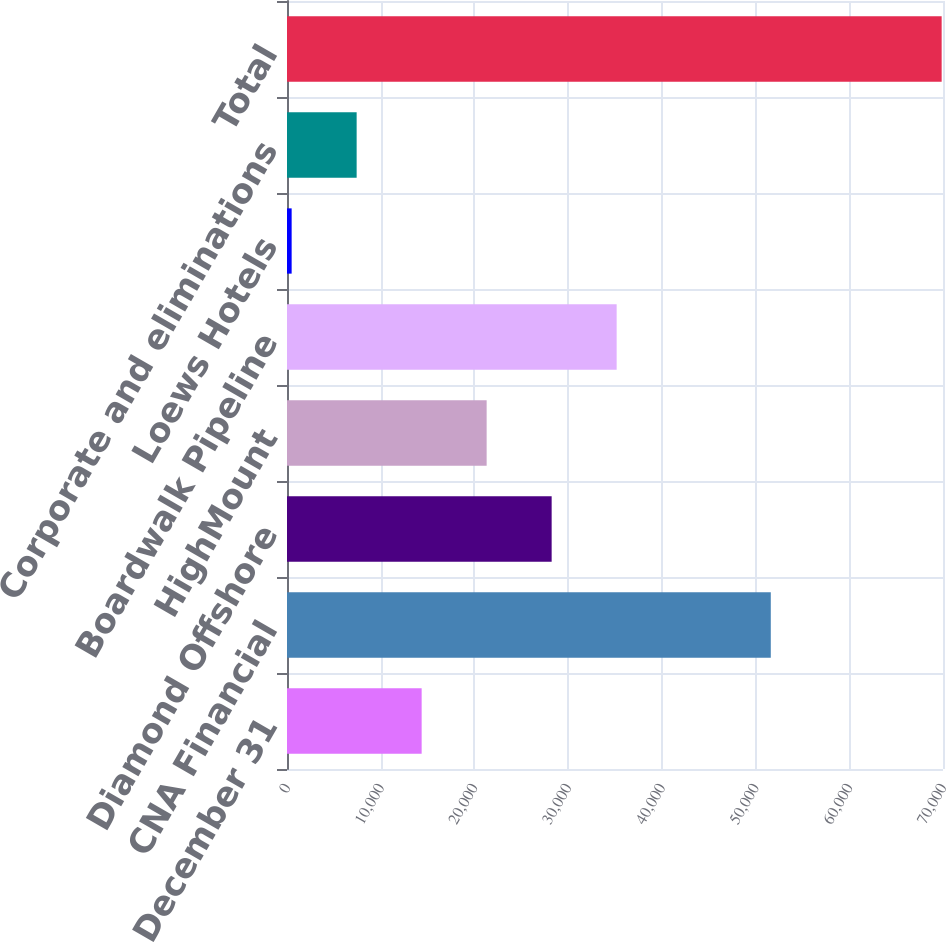Convert chart to OTSL. <chart><loc_0><loc_0><loc_500><loc_500><bar_chart><fcel>December 31<fcel>CNA Financial<fcel>Diamond Offshore<fcel>HighMount<fcel>Boardwalk Pipeline<fcel>Loews Hotels<fcel>Corporate and eliminations<fcel>Total<nl><fcel>14368.2<fcel>51624<fcel>28240.4<fcel>21304.3<fcel>35176.5<fcel>496<fcel>7432.1<fcel>69857<nl></chart> 